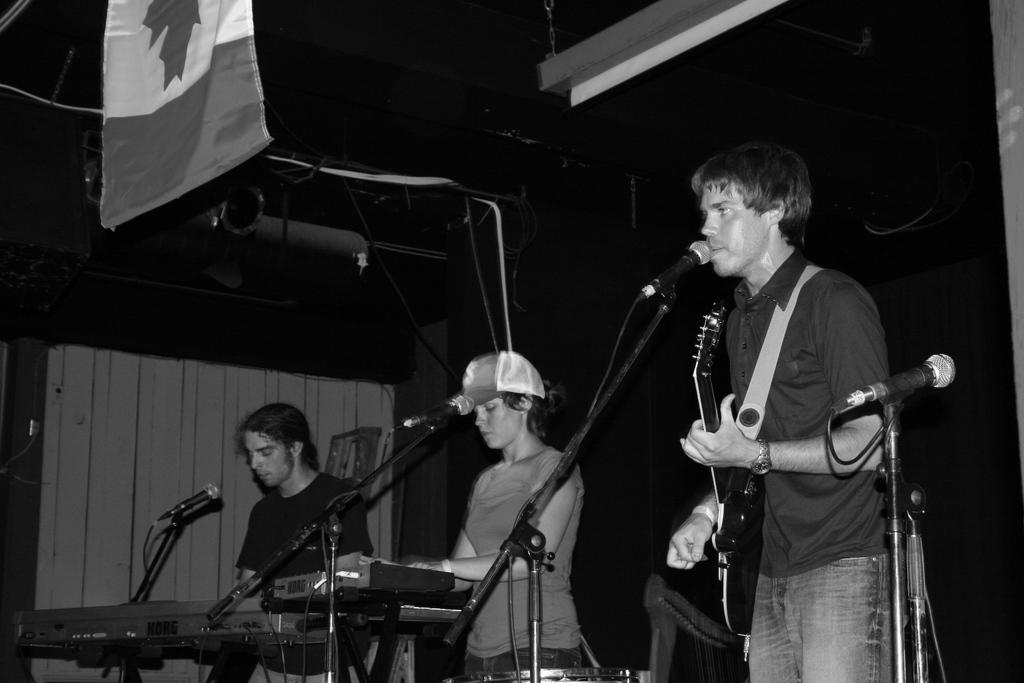How many people are in the image? There are three people in the image. What is one of the people doing in the image? One of the people is holding a guitar. What animals are present in front of the people? There are mice in front of the people. What additional object can be seen in the image? There is a flag in the image. What type of force is being applied to the mice in the image? There is no force being applied to the mice in the image; they are simply present in front of the people. Can you locate a map in the image? There is no map present in the image. 